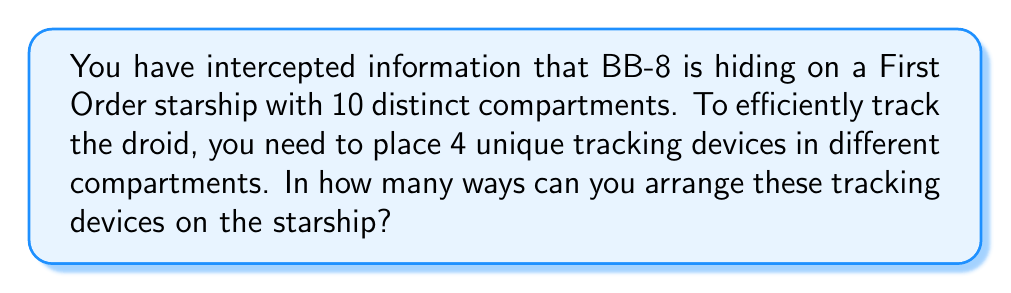Provide a solution to this math problem. Let's approach this step-by-step:

1) This is a permutation problem. We are selecting 4 compartments out of 10 and arranging our 4 unique tracking devices in these compartments.

2) The number of ways to select 4 compartments out of 10 is given by the combination formula:

   $$\binom{10}{4} = \frac{10!}{4!(10-4)!} = \frac{10!}{4!6!}$$

3) Once we've selected the 4 compartments, we need to arrange our 4 unique tracking devices in these compartments. This is a permutation of 4 items, which is simply 4!.

4) By the multiplication principle, the total number of ways to arrange the tracking devices is:

   $$\binom{10}{4} \times 4!$$

5) Let's calculate this:
   
   $$\binom{10}{4} = \frac{10!}{4!6!} = \frac{10 \times 9 \times 8 \times 7}{4 \times 3 \times 2 \times 1} = 210$$

   $$210 \times 4! = 210 \times 24 = 5040$$

Therefore, there are 5040 unique ways to arrange the tracking devices on the starship.
Answer: 5040 